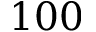Convert formula to latex. <formula><loc_0><loc_0><loc_500><loc_500>1 0 0</formula> 